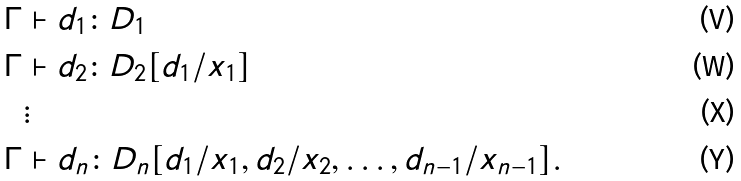Convert formula to latex. <formula><loc_0><loc_0><loc_500><loc_500>\Gamma & \vdash d _ { 1 } \colon D _ { 1 } \\ \Gamma & \vdash d _ { 2 } \colon D _ { 2 } [ d _ { 1 } / x _ { 1 } ] \\ & \vdots \\ \Gamma & \vdash d _ { n } \colon D _ { n } [ d _ { 1 } / x _ { 1 } , d _ { 2 } / x _ { 2 } , \dots , d _ { n - 1 } / x _ { n - 1 } ] .</formula> 